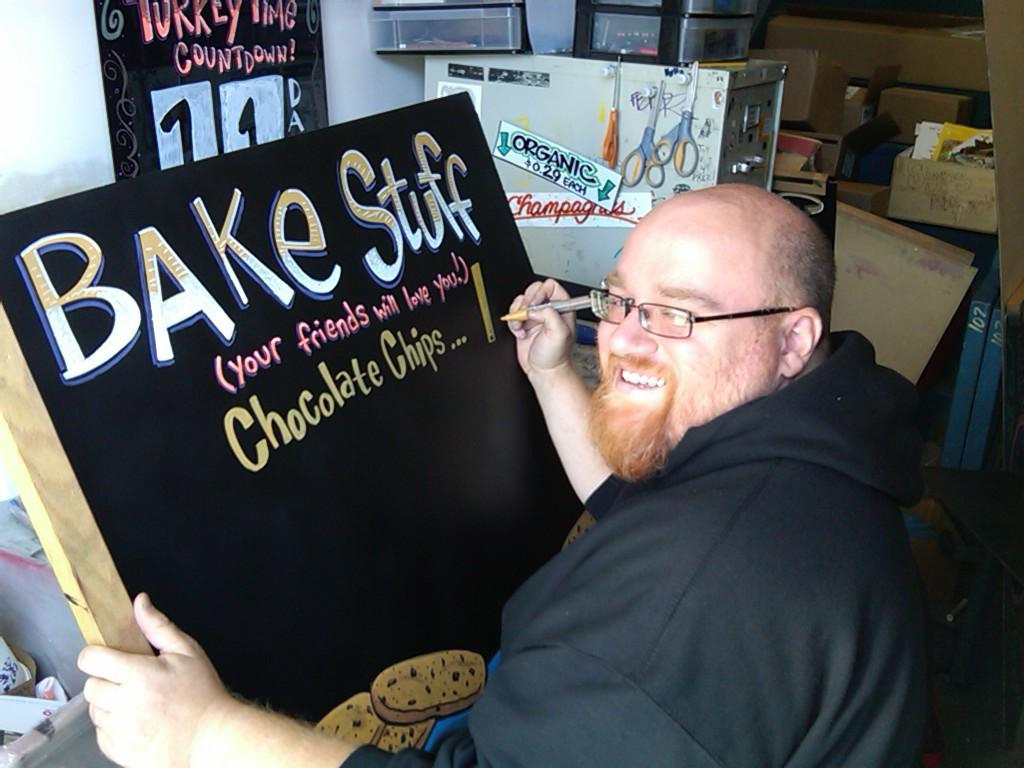Provide a one-sentence caption for the provided image. The man is creating a sign for a bake sale with different items. 